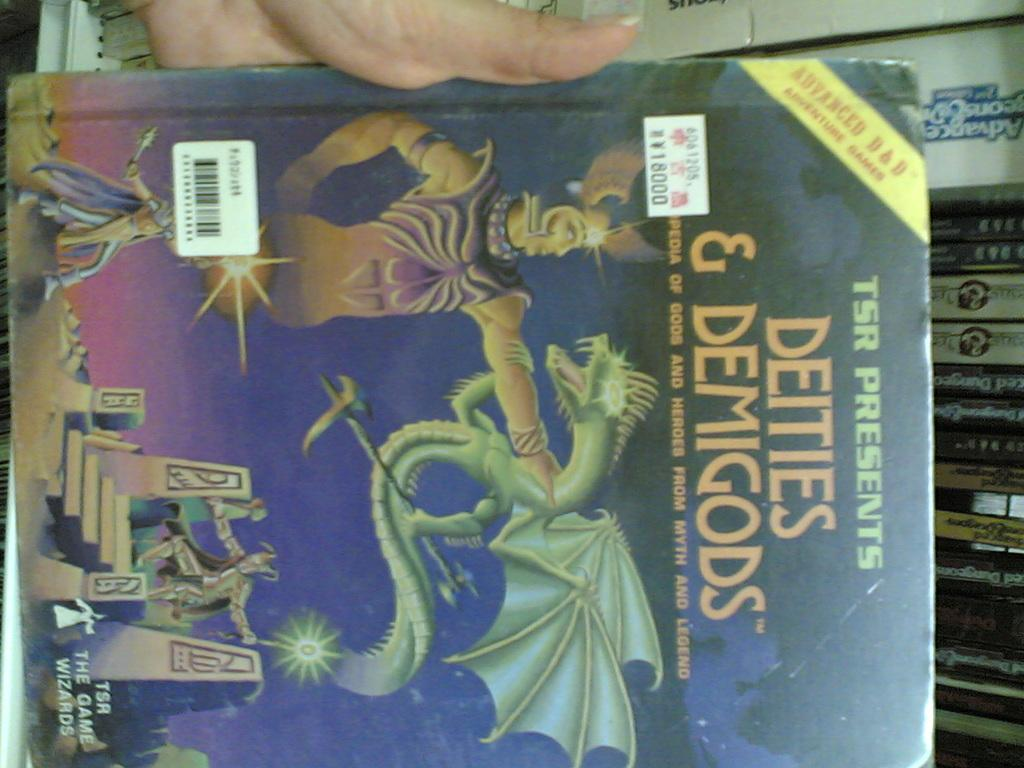<image>
Present a compact description of the photo's key features. A copy of the book Deities & Demigods. 